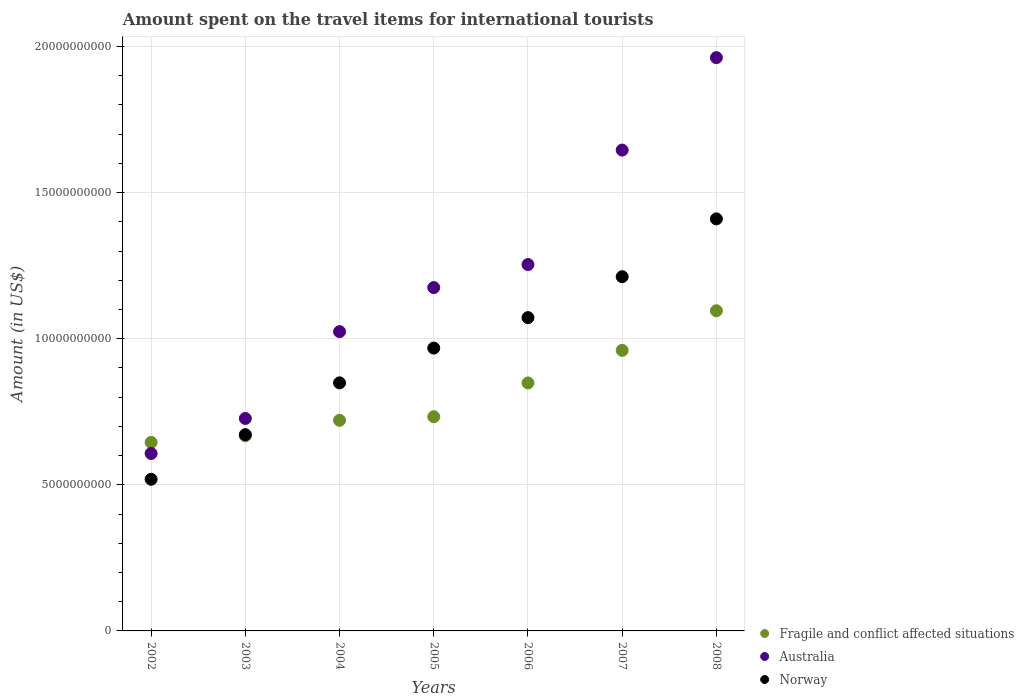Is the number of dotlines equal to the number of legend labels?
Keep it short and to the point. Yes. What is the amount spent on the travel items for international tourists in Australia in 2004?
Keep it short and to the point. 1.02e+1. Across all years, what is the maximum amount spent on the travel items for international tourists in Fragile and conflict affected situations?
Your answer should be compact. 1.10e+1. Across all years, what is the minimum amount spent on the travel items for international tourists in Fragile and conflict affected situations?
Offer a terse response. 6.45e+09. What is the total amount spent on the travel items for international tourists in Fragile and conflict affected situations in the graph?
Provide a succinct answer. 5.67e+1. What is the difference between the amount spent on the travel items for international tourists in Australia in 2003 and that in 2006?
Offer a very short reply. -5.27e+09. What is the difference between the amount spent on the travel items for international tourists in Australia in 2002 and the amount spent on the travel items for international tourists in Norway in 2008?
Make the answer very short. -8.03e+09. What is the average amount spent on the travel items for international tourists in Fragile and conflict affected situations per year?
Keep it short and to the point. 8.10e+09. In the year 2004, what is the difference between the amount spent on the travel items for international tourists in Norway and amount spent on the travel items for international tourists in Australia?
Provide a succinct answer. -1.75e+09. In how many years, is the amount spent on the travel items for international tourists in Norway greater than 17000000000 US$?
Offer a very short reply. 0. What is the ratio of the amount spent on the travel items for international tourists in Australia in 2006 to that in 2007?
Provide a succinct answer. 0.76. Is the amount spent on the travel items for international tourists in Fragile and conflict affected situations in 2002 less than that in 2006?
Your answer should be very brief. Yes. Is the difference between the amount spent on the travel items for international tourists in Norway in 2004 and 2006 greater than the difference between the amount spent on the travel items for international tourists in Australia in 2004 and 2006?
Your response must be concise. Yes. What is the difference between the highest and the second highest amount spent on the travel items for international tourists in Australia?
Offer a very short reply. 3.16e+09. What is the difference between the highest and the lowest amount spent on the travel items for international tourists in Australia?
Your answer should be compact. 1.35e+1. In how many years, is the amount spent on the travel items for international tourists in Fragile and conflict affected situations greater than the average amount spent on the travel items for international tourists in Fragile and conflict affected situations taken over all years?
Ensure brevity in your answer.  3. Is it the case that in every year, the sum of the amount spent on the travel items for international tourists in Fragile and conflict affected situations and amount spent on the travel items for international tourists in Norway  is greater than the amount spent on the travel items for international tourists in Australia?
Offer a terse response. Yes. Is the amount spent on the travel items for international tourists in Australia strictly less than the amount spent on the travel items for international tourists in Fragile and conflict affected situations over the years?
Your response must be concise. No. How many years are there in the graph?
Provide a succinct answer. 7. What is the difference between two consecutive major ticks on the Y-axis?
Keep it short and to the point. 5.00e+09. Does the graph contain any zero values?
Provide a succinct answer. No. Where does the legend appear in the graph?
Your response must be concise. Bottom right. What is the title of the graph?
Keep it short and to the point. Amount spent on the travel items for international tourists. Does "Kazakhstan" appear as one of the legend labels in the graph?
Your answer should be compact. No. What is the label or title of the Y-axis?
Your response must be concise. Amount (in US$). What is the Amount (in US$) in Fragile and conflict affected situations in 2002?
Your answer should be compact. 6.45e+09. What is the Amount (in US$) in Australia in 2002?
Offer a very short reply. 6.07e+09. What is the Amount (in US$) in Norway in 2002?
Give a very brief answer. 5.19e+09. What is the Amount (in US$) in Fragile and conflict affected situations in 2003?
Ensure brevity in your answer.  6.68e+09. What is the Amount (in US$) in Australia in 2003?
Offer a terse response. 7.27e+09. What is the Amount (in US$) of Norway in 2003?
Your answer should be very brief. 6.72e+09. What is the Amount (in US$) of Fragile and conflict affected situations in 2004?
Provide a short and direct response. 7.21e+09. What is the Amount (in US$) in Australia in 2004?
Keep it short and to the point. 1.02e+1. What is the Amount (in US$) of Norway in 2004?
Provide a succinct answer. 8.49e+09. What is the Amount (in US$) of Fragile and conflict affected situations in 2005?
Ensure brevity in your answer.  7.33e+09. What is the Amount (in US$) of Australia in 2005?
Provide a short and direct response. 1.17e+1. What is the Amount (in US$) of Norway in 2005?
Keep it short and to the point. 9.68e+09. What is the Amount (in US$) in Fragile and conflict affected situations in 2006?
Ensure brevity in your answer.  8.49e+09. What is the Amount (in US$) of Australia in 2006?
Provide a short and direct response. 1.25e+1. What is the Amount (in US$) of Norway in 2006?
Offer a terse response. 1.07e+1. What is the Amount (in US$) of Fragile and conflict affected situations in 2007?
Give a very brief answer. 9.60e+09. What is the Amount (in US$) of Australia in 2007?
Offer a very short reply. 1.65e+1. What is the Amount (in US$) of Norway in 2007?
Your response must be concise. 1.21e+1. What is the Amount (in US$) in Fragile and conflict affected situations in 2008?
Offer a very short reply. 1.10e+1. What is the Amount (in US$) of Australia in 2008?
Provide a succinct answer. 1.96e+1. What is the Amount (in US$) of Norway in 2008?
Your answer should be compact. 1.41e+1. Across all years, what is the maximum Amount (in US$) of Fragile and conflict affected situations?
Give a very brief answer. 1.10e+1. Across all years, what is the maximum Amount (in US$) in Australia?
Provide a short and direct response. 1.96e+1. Across all years, what is the maximum Amount (in US$) of Norway?
Ensure brevity in your answer.  1.41e+1. Across all years, what is the minimum Amount (in US$) in Fragile and conflict affected situations?
Your answer should be very brief. 6.45e+09. Across all years, what is the minimum Amount (in US$) in Australia?
Make the answer very short. 6.07e+09. Across all years, what is the minimum Amount (in US$) of Norway?
Your answer should be compact. 5.19e+09. What is the total Amount (in US$) in Fragile and conflict affected situations in the graph?
Offer a terse response. 5.67e+1. What is the total Amount (in US$) of Australia in the graph?
Provide a short and direct response. 8.39e+1. What is the total Amount (in US$) in Norway in the graph?
Make the answer very short. 6.70e+1. What is the difference between the Amount (in US$) in Fragile and conflict affected situations in 2002 and that in 2003?
Ensure brevity in your answer.  -2.28e+08. What is the difference between the Amount (in US$) in Australia in 2002 and that in 2003?
Make the answer very short. -1.20e+09. What is the difference between the Amount (in US$) in Norway in 2002 and that in 2003?
Keep it short and to the point. -1.53e+09. What is the difference between the Amount (in US$) of Fragile and conflict affected situations in 2002 and that in 2004?
Ensure brevity in your answer.  -7.56e+08. What is the difference between the Amount (in US$) of Australia in 2002 and that in 2004?
Your response must be concise. -4.17e+09. What is the difference between the Amount (in US$) in Norway in 2002 and that in 2004?
Provide a succinct answer. -3.30e+09. What is the difference between the Amount (in US$) of Fragile and conflict affected situations in 2002 and that in 2005?
Your answer should be compact. -8.79e+08. What is the difference between the Amount (in US$) in Australia in 2002 and that in 2005?
Provide a succinct answer. -5.68e+09. What is the difference between the Amount (in US$) in Norway in 2002 and that in 2005?
Offer a terse response. -4.49e+09. What is the difference between the Amount (in US$) of Fragile and conflict affected situations in 2002 and that in 2006?
Make the answer very short. -2.03e+09. What is the difference between the Amount (in US$) in Australia in 2002 and that in 2006?
Your answer should be compact. -6.46e+09. What is the difference between the Amount (in US$) in Norway in 2002 and that in 2006?
Offer a very short reply. -5.53e+09. What is the difference between the Amount (in US$) in Fragile and conflict affected situations in 2002 and that in 2007?
Your answer should be very brief. -3.15e+09. What is the difference between the Amount (in US$) of Australia in 2002 and that in 2007?
Your answer should be compact. -1.04e+1. What is the difference between the Amount (in US$) of Norway in 2002 and that in 2007?
Provide a short and direct response. -6.93e+09. What is the difference between the Amount (in US$) in Fragile and conflict affected situations in 2002 and that in 2008?
Give a very brief answer. -4.50e+09. What is the difference between the Amount (in US$) of Australia in 2002 and that in 2008?
Make the answer very short. -1.35e+1. What is the difference between the Amount (in US$) of Norway in 2002 and that in 2008?
Make the answer very short. -8.91e+09. What is the difference between the Amount (in US$) of Fragile and conflict affected situations in 2003 and that in 2004?
Offer a very short reply. -5.28e+08. What is the difference between the Amount (in US$) of Australia in 2003 and that in 2004?
Make the answer very short. -2.97e+09. What is the difference between the Amount (in US$) in Norway in 2003 and that in 2004?
Your answer should be compact. -1.77e+09. What is the difference between the Amount (in US$) in Fragile and conflict affected situations in 2003 and that in 2005?
Offer a terse response. -6.51e+08. What is the difference between the Amount (in US$) in Australia in 2003 and that in 2005?
Give a very brief answer. -4.48e+09. What is the difference between the Amount (in US$) of Norway in 2003 and that in 2005?
Your answer should be compact. -2.96e+09. What is the difference between the Amount (in US$) of Fragile and conflict affected situations in 2003 and that in 2006?
Give a very brief answer. -1.81e+09. What is the difference between the Amount (in US$) of Australia in 2003 and that in 2006?
Offer a very short reply. -5.27e+09. What is the difference between the Amount (in US$) in Norway in 2003 and that in 2006?
Your answer should be very brief. -4.00e+09. What is the difference between the Amount (in US$) of Fragile and conflict affected situations in 2003 and that in 2007?
Ensure brevity in your answer.  -2.92e+09. What is the difference between the Amount (in US$) in Australia in 2003 and that in 2007?
Your answer should be very brief. -9.18e+09. What is the difference between the Amount (in US$) of Norway in 2003 and that in 2007?
Keep it short and to the point. -5.40e+09. What is the difference between the Amount (in US$) in Fragile and conflict affected situations in 2003 and that in 2008?
Your answer should be very brief. -4.28e+09. What is the difference between the Amount (in US$) in Australia in 2003 and that in 2008?
Keep it short and to the point. -1.23e+1. What is the difference between the Amount (in US$) in Norway in 2003 and that in 2008?
Keep it short and to the point. -7.38e+09. What is the difference between the Amount (in US$) of Fragile and conflict affected situations in 2004 and that in 2005?
Provide a succinct answer. -1.23e+08. What is the difference between the Amount (in US$) of Australia in 2004 and that in 2005?
Give a very brief answer. -1.51e+09. What is the difference between the Amount (in US$) of Norway in 2004 and that in 2005?
Offer a terse response. -1.19e+09. What is the difference between the Amount (in US$) of Fragile and conflict affected situations in 2004 and that in 2006?
Your answer should be compact. -1.28e+09. What is the difference between the Amount (in US$) in Australia in 2004 and that in 2006?
Provide a short and direct response. -2.30e+09. What is the difference between the Amount (in US$) of Norway in 2004 and that in 2006?
Ensure brevity in your answer.  -2.23e+09. What is the difference between the Amount (in US$) of Fragile and conflict affected situations in 2004 and that in 2007?
Your answer should be compact. -2.39e+09. What is the difference between the Amount (in US$) of Australia in 2004 and that in 2007?
Provide a succinct answer. -6.21e+09. What is the difference between the Amount (in US$) of Norway in 2004 and that in 2007?
Your response must be concise. -3.63e+09. What is the difference between the Amount (in US$) in Fragile and conflict affected situations in 2004 and that in 2008?
Your answer should be compact. -3.75e+09. What is the difference between the Amount (in US$) of Australia in 2004 and that in 2008?
Offer a very short reply. -9.38e+09. What is the difference between the Amount (in US$) in Norway in 2004 and that in 2008?
Your response must be concise. -5.61e+09. What is the difference between the Amount (in US$) in Fragile and conflict affected situations in 2005 and that in 2006?
Offer a terse response. -1.16e+09. What is the difference between the Amount (in US$) of Australia in 2005 and that in 2006?
Provide a succinct answer. -7.88e+08. What is the difference between the Amount (in US$) in Norway in 2005 and that in 2006?
Keep it short and to the point. -1.04e+09. What is the difference between the Amount (in US$) in Fragile and conflict affected situations in 2005 and that in 2007?
Your answer should be compact. -2.27e+09. What is the difference between the Amount (in US$) in Australia in 2005 and that in 2007?
Provide a short and direct response. -4.70e+09. What is the difference between the Amount (in US$) in Norway in 2005 and that in 2007?
Ensure brevity in your answer.  -2.44e+09. What is the difference between the Amount (in US$) of Fragile and conflict affected situations in 2005 and that in 2008?
Your answer should be very brief. -3.63e+09. What is the difference between the Amount (in US$) in Australia in 2005 and that in 2008?
Provide a short and direct response. -7.87e+09. What is the difference between the Amount (in US$) in Norway in 2005 and that in 2008?
Ensure brevity in your answer.  -4.42e+09. What is the difference between the Amount (in US$) of Fragile and conflict affected situations in 2006 and that in 2007?
Give a very brief answer. -1.11e+09. What is the difference between the Amount (in US$) of Australia in 2006 and that in 2007?
Keep it short and to the point. -3.92e+09. What is the difference between the Amount (in US$) of Norway in 2006 and that in 2007?
Provide a short and direct response. -1.40e+09. What is the difference between the Amount (in US$) in Fragile and conflict affected situations in 2006 and that in 2008?
Your answer should be compact. -2.47e+09. What is the difference between the Amount (in US$) in Australia in 2006 and that in 2008?
Keep it short and to the point. -7.08e+09. What is the difference between the Amount (in US$) of Norway in 2006 and that in 2008?
Offer a terse response. -3.38e+09. What is the difference between the Amount (in US$) in Fragile and conflict affected situations in 2007 and that in 2008?
Provide a succinct answer. -1.35e+09. What is the difference between the Amount (in US$) in Australia in 2007 and that in 2008?
Keep it short and to the point. -3.16e+09. What is the difference between the Amount (in US$) in Norway in 2007 and that in 2008?
Provide a succinct answer. -1.98e+09. What is the difference between the Amount (in US$) in Fragile and conflict affected situations in 2002 and the Amount (in US$) in Australia in 2003?
Your answer should be compact. -8.19e+08. What is the difference between the Amount (in US$) in Fragile and conflict affected situations in 2002 and the Amount (in US$) in Norway in 2003?
Give a very brief answer. -2.65e+08. What is the difference between the Amount (in US$) of Australia in 2002 and the Amount (in US$) of Norway in 2003?
Offer a very short reply. -6.44e+08. What is the difference between the Amount (in US$) in Fragile and conflict affected situations in 2002 and the Amount (in US$) in Australia in 2004?
Keep it short and to the point. -3.79e+09. What is the difference between the Amount (in US$) in Fragile and conflict affected situations in 2002 and the Amount (in US$) in Norway in 2004?
Offer a terse response. -2.04e+09. What is the difference between the Amount (in US$) of Australia in 2002 and the Amount (in US$) of Norway in 2004?
Provide a succinct answer. -2.42e+09. What is the difference between the Amount (in US$) in Fragile and conflict affected situations in 2002 and the Amount (in US$) in Australia in 2005?
Make the answer very short. -5.30e+09. What is the difference between the Amount (in US$) of Fragile and conflict affected situations in 2002 and the Amount (in US$) of Norway in 2005?
Your answer should be compact. -3.23e+09. What is the difference between the Amount (in US$) of Australia in 2002 and the Amount (in US$) of Norway in 2005?
Offer a very short reply. -3.61e+09. What is the difference between the Amount (in US$) in Fragile and conflict affected situations in 2002 and the Amount (in US$) in Australia in 2006?
Make the answer very short. -6.09e+09. What is the difference between the Amount (in US$) in Fragile and conflict affected situations in 2002 and the Amount (in US$) in Norway in 2006?
Your answer should be very brief. -4.27e+09. What is the difference between the Amount (in US$) of Australia in 2002 and the Amount (in US$) of Norway in 2006?
Your response must be concise. -4.65e+09. What is the difference between the Amount (in US$) of Fragile and conflict affected situations in 2002 and the Amount (in US$) of Australia in 2007?
Provide a short and direct response. -1.00e+1. What is the difference between the Amount (in US$) in Fragile and conflict affected situations in 2002 and the Amount (in US$) in Norway in 2007?
Provide a short and direct response. -5.67e+09. What is the difference between the Amount (in US$) in Australia in 2002 and the Amount (in US$) in Norway in 2007?
Keep it short and to the point. -6.05e+09. What is the difference between the Amount (in US$) in Fragile and conflict affected situations in 2002 and the Amount (in US$) in Australia in 2008?
Provide a succinct answer. -1.32e+1. What is the difference between the Amount (in US$) of Fragile and conflict affected situations in 2002 and the Amount (in US$) of Norway in 2008?
Your answer should be very brief. -7.65e+09. What is the difference between the Amount (in US$) of Australia in 2002 and the Amount (in US$) of Norway in 2008?
Your answer should be very brief. -8.03e+09. What is the difference between the Amount (in US$) of Fragile and conflict affected situations in 2003 and the Amount (in US$) of Australia in 2004?
Your response must be concise. -3.56e+09. What is the difference between the Amount (in US$) of Fragile and conflict affected situations in 2003 and the Amount (in US$) of Norway in 2004?
Your answer should be compact. -1.81e+09. What is the difference between the Amount (in US$) of Australia in 2003 and the Amount (in US$) of Norway in 2004?
Your answer should be compact. -1.22e+09. What is the difference between the Amount (in US$) in Fragile and conflict affected situations in 2003 and the Amount (in US$) in Australia in 2005?
Ensure brevity in your answer.  -5.07e+09. What is the difference between the Amount (in US$) in Fragile and conflict affected situations in 2003 and the Amount (in US$) in Norway in 2005?
Provide a short and direct response. -3.00e+09. What is the difference between the Amount (in US$) in Australia in 2003 and the Amount (in US$) in Norway in 2005?
Offer a terse response. -2.41e+09. What is the difference between the Amount (in US$) of Fragile and conflict affected situations in 2003 and the Amount (in US$) of Australia in 2006?
Make the answer very short. -5.86e+09. What is the difference between the Amount (in US$) in Fragile and conflict affected situations in 2003 and the Amount (in US$) in Norway in 2006?
Ensure brevity in your answer.  -4.04e+09. What is the difference between the Amount (in US$) of Australia in 2003 and the Amount (in US$) of Norway in 2006?
Offer a very short reply. -3.45e+09. What is the difference between the Amount (in US$) in Fragile and conflict affected situations in 2003 and the Amount (in US$) in Australia in 2007?
Your answer should be very brief. -9.77e+09. What is the difference between the Amount (in US$) in Fragile and conflict affected situations in 2003 and the Amount (in US$) in Norway in 2007?
Keep it short and to the point. -5.44e+09. What is the difference between the Amount (in US$) in Australia in 2003 and the Amount (in US$) in Norway in 2007?
Provide a short and direct response. -4.85e+09. What is the difference between the Amount (in US$) in Fragile and conflict affected situations in 2003 and the Amount (in US$) in Australia in 2008?
Make the answer very short. -1.29e+1. What is the difference between the Amount (in US$) of Fragile and conflict affected situations in 2003 and the Amount (in US$) of Norway in 2008?
Your response must be concise. -7.42e+09. What is the difference between the Amount (in US$) in Australia in 2003 and the Amount (in US$) in Norway in 2008?
Make the answer very short. -6.83e+09. What is the difference between the Amount (in US$) in Fragile and conflict affected situations in 2004 and the Amount (in US$) in Australia in 2005?
Offer a terse response. -4.54e+09. What is the difference between the Amount (in US$) in Fragile and conflict affected situations in 2004 and the Amount (in US$) in Norway in 2005?
Your answer should be very brief. -2.47e+09. What is the difference between the Amount (in US$) in Australia in 2004 and the Amount (in US$) in Norway in 2005?
Give a very brief answer. 5.64e+08. What is the difference between the Amount (in US$) of Fragile and conflict affected situations in 2004 and the Amount (in US$) of Australia in 2006?
Make the answer very short. -5.33e+09. What is the difference between the Amount (in US$) in Fragile and conflict affected situations in 2004 and the Amount (in US$) in Norway in 2006?
Your answer should be very brief. -3.51e+09. What is the difference between the Amount (in US$) in Australia in 2004 and the Amount (in US$) in Norway in 2006?
Ensure brevity in your answer.  -4.79e+08. What is the difference between the Amount (in US$) in Fragile and conflict affected situations in 2004 and the Amount (in US$) in Australia in 2007?
Give a very brief answer. -9.25e+09. What is the difference between the Amount (in US$) in Fragile and conflict affected situations in 2004 and the Amount (in US$) in Norway in 2007?
Offer a terse response. -4.91e+09. What is the difference between the Amount (in US$) of Australia in 2004 and the Amount (in US$) of Norway in 2007?
Make the answer very short. -1.88e+09. What is the difference between the Amount (in US$) in Fragile and conflict affected situations in 2004 and the Amount (in US$) in Australia in 2008?
Keep it short and to the point. -1.24e+1. What is the difference between the Amount (in US$) of Fragile and conflict affected situations in 2004 and the Amount (in US$) of Norway in 2008?
Offer a terse response. -6.89e+09. What is the difference between the Amount (in US$) of Australia in 2004 and the Amount (in US$) of Norway in 2008?
Your response must be concise. -3.86e+09. What is the difference between the Amount (in US$) of Fragile and conflict affected situations in 2005 and the Amount (in US$) of Australia in 2006?
Offer a very short reply. -5.21e+09. What is the difference between the Amount (in US$) of Fragile and conflict affected situations in 2005 and the Amount (in US$) of Norway in 2006?
Your response must be concise. -3.39e+09. What is the difference between the Amount (in US$) in Australia in 2005 and the Amount (in US$) in Norway in 2006?
Make the answer very short. 1.03e+09. What is the difference between the Amount (in US$) in Fragile and conflict affected situations in 2005 and the Amount (in US$) in Australia in 2007?
Ensure brevity in your answer.  -9.12e+09. What is the difference between the Amount (in US$) of Fragile and conflict affected situations in 2005 and the Amount (in US$) of Norway in 2007?
Provide a succinct answer. -4.79e+09. What is the difference between the Amount (in US$) in Australia in 2005 and the Amount (in US$) in Norway in 2007?
Your answer should be compact. -3.72e+08. What is the difference between the Amount (in US$) of Fragile and conflict affected situations in 2005 and the Amount (in US$) of Australia in 2008?
Offer a very short reply. -1.23e+1. What is the difference between the Amount (in US$) in Fragile and conflict affected situations in 2005 and the Amount (in US$) in Norway in 2008?
Offer a terse response. -6.77e+09. What is the difference between the Amount (in US$) of Australia in 2005 and the Amount (in US$) of Norway in 2008?
Ensure brevity in your answer.  -2.35e+09. What is the difference between the Amount (in US$) of Fragile and conflict affected situations in 2006 and the Amount (in US$) of Australia in 2007?
Make the answer very short. -7.97e+09. What is the difference between the Amount (in US$) in Fragile and conflict affected situations in 2006 and the Amount (in US$) in Norway in 2007?
Ensure brevity in your answer.  -3.63e+09. What is the difference between the Amount (in US$) in Australia in 2006 and the Amount (in US$) in Norway in 2007?
Keep it short and to the point. 4.16e+08. What is the difference between the Amount (in US$) in Fragile and conflict affected situations in 2006 and the Amount (in US$) in Australia in 2008?
Provide a short and direct response. -1.11e+1. What is the difference between the Amount (in US$) of Fragile and conflict affected situations in 2006 and the Amount (in US$) of Norway in 2008?
Ensure brevity in your answer.  -5.61e+09. What is the difference between the Amount (in US$) in Australia in 2006 and the Amount (in US$) in Norway in 2008?
Your response must be concise. -1.56e+09. What is the difference between the Amount (in US$) of Fragile and conflict affected situations in 2007 and the Amount (in US$) of Australia in 2008?
Offer a terse response. -1.00e+1. What is the difference between the Amount (in US$) in Fragile and conflict affected situations in 2007 and the Amount (in US$) in Norway in 2008?
Make the answer very short. -4.50e+09. What is the difference between the Amount (in US$) of Australia in 2007 and the Amount (in US$) of Norway in 2008?
Keep it short and to the point. 2.35e+09. What is the average Amount (in US$) of Fragile and conflict affected situations per year?
Offer a very short reply. 8.10e+09. What is the average Amount (in US$) in Australia per year?
Provide a short and direct response. 1.20e+1. What is the average Amount (in US$) in Norway per year?
Your answer should be very brief. 9.57e+09. In the year 2002, what is the difference between the Amount (in US$) of Fragile and conflict affected situations and Amount (in US$) of Australia?
Give a very brief answer. 3.79e+08. In the year 2002, what is the difference between the Amount (in US$) in Fragile and conflict affected situations and Amount (in US$) in Norway?
Make the answer very short. 1.26e+09. In the year 2002, what is the difference between the Amount (in US$) in Australia and Amount (in US$) in Norway?
Provide a short and direct response. 8.83e+08. In the year 2003, what is the difference between the Amount (in US$) in Fragile and conflict affected situations and Amount (in US$) in Australia?
Give a very brief answer. -5.91e+08. In the year 2003, what is the difference between the Amount (in US$) of Fragile and conflict affected situations and Amount (in US$) of Norway?
Provide a succinct answer. -3.69e+07. In the year 2003, what is the difference between the Amount (in US$) in Australia and Amount (in US$) in Norway?
Offer a very short reply. 5.54e+08. In the year 2004, what is the difference between the Amount (in US$) in Fragile and conflict affected situations and Amount (in US$) in Australia?
Provide a short and direct response. -3.03e+09. In the year 2004, what is the difference between the Amount (in US$) in Fragile and conflict affected situations and Amount (in US$) in Norway?
Provide a short and direct response. -1.28e+09. In the year 2004, what is the difference between the Amount (in US$) in Australia and Amount (in US$) in Norway?
Your answer should be compact. 1.75e+09. In the year 2005, what is the difference between the Amount (in US$) of Fragile and conflict affected situations and Amount (in US$) of Australia?
Make the answer very short. -4.42e+09. In the year 2005, what is the difference between the Amount (in US$) of Fragile and conflict affected situations and Amount (in US$) of Norway?
Ensure brevity in your answer.  -2.35e+09. In the year 2005, what is the difference between the Amount (in US$) of Australia and Amount (in US$) of Norway?
Your response must be concise. 2.07e+09. In the year 2006, what is the difference between the Amount (in US$) of Fragile and conflict affected situations and Amount (in US$) of Australia?
Keep it short and to the point. -4.05e+09. In the year 2006, what is the difference between the Amount (in US$) in Fragile and conflict affected situations and Amount (in US$) in Norway?
Provide a succinct answer. -2.23e+09. In the year 2006, what is the difference between the Amount (in US$) of Australia and Amount (in US$) of Norway?
Provide a succinct answer. 1.82e+09. In the year 2007, what is the difference between the Amount (in US$) of Fragile and conflict affected situations and Amount (in US$) of Australia?
Make the answer very short. -6.85e+09. In the year 2007, what is the difference between the Amount (in US$) of Fragile and conflict affected situations and Amount (in US$) of Norway?
Provide a succinct answer. -2.52e+09. In the year 2007, what is the difference between the Amount (in US$) in Australia and Amount (in US$) in Norway?
Your answer should be very brief. 4.33e+09. In the year 2008, what is the difference between the Amount (in US$) of Fragile and conflict affected situations and Amount (in US$) of Australia?
Your response must be concise. -8.66e+09. In the year 2008, what is the difference between the Amount (in US$) of Fragile and conflict affected situations and Amount (in US$) of Norway?
Your answer should be compact. -3.14e+09. In the year 2008, what is the difference between the Amount (in US$) of Australia and Amount (in US$) of Norway?
Provide a succinct answer. 5.52e+09. What is the ratio of the Amount (in US$) in Fragile and conflict affected situations in 2002 to that in 2003?
Keep it short and to the point. 0.97. What is the ratio of the Amount (in US$) in Australia in 2002 to that in 2003?
Offer a very short reply. 0.84. What is the ratio of the Amount (in US$) of Norway in 2002 to that in 2003?
Ensure brevity in your answer.  0.77. What is the ratio of the Amount (in US$) in Fragile and conflict affected situations in 2002 to that in 2004?
Ensure brevity in your answer.  0.9. What is the ratio of the Amount (in US$) in Australia in 2002 to that in 2004?
Offer a terse response. 0.59. What is the ratio of the Amount (in US$) in Norway in 2002 to that in 2004?
Provide a short and direct response. 0.61. What is the ratio of the Amount (in US$) of Fragile and conflict affected situations in 2002 to that in 2005?
Your answer should be very brief. 0.88. What is the ratio of the Amount (in US$) in Australia in 2002 to that in 2005?
Make the answer very short. 0.52. What is the ratio of the Amount (in US$) in Norway in 2002 to that in 2005?
Offer a terse response. 0.54. What is the ratio of the Amount (in US$) in Fragile and conflict affected situations in 2002 to that in 2006?
Your answer should be compact. 0.76. What is the ratio of the Amount (in US$) of Australia in 2002 to that in 2006?
Your response must be concise. 0.48. What is the ratio of the Amount (in US$) of Norway in 2002 to that in 2006?
Your response must be concise. 0.48. What is the ratio of the Amount (in US$) in Fragile and conflict affected situations in 2002 to that in 2007?
Offer a very short reply. 0.67. What is the ratio of the Amount (in US$) of Australia in 2002 to that in 2007?
Offer a terse response. 0.37. What is the ratio of the Amount (in US$) in Norway in 2002 to that in 2007?
Keep it short and to the point. 0.43. What is the ratio of the Amount (in US$) in Fragile and conflict affected situations in 2002 to that in 2008?
Your answer should be compact. 0.59. What is the ratio of the Amount (in US$) of Australia in 2002 to that in 2008?
Your answer should be very brief. 0.31. What is the ratio of the Amount (in US$) of Norway in 2002 to that in 2008?
Keep it short and to the point. 0.37. What is the ratio of the Amount (in US$) in Fragile and conflict affected situations in 2003 to that in 2004?
Your answer should be very brief. 0.93. What is the ratio of the Amount (in US$) of Australia in 2003 to that in 2004?
Your answer should be compact. 0.71. What is the ratio of the Amount (in US$) in Norway in 2003 to that in 2004?
Your response must be concise. 0.79. What is the ratio of the Amount (in US$) in Fragile and conflict affected situations in 2003 to that in 2005?
Your response must be concise. 0.91. What is the ratio of the Amount (in US$) of Australia in 2003 to that in 2005?
Offer a very short reply. 0.62. What is the ratio of the Amount (in US$) in Norway in 2003 to that in 2005?
Ensure brevity in your answer.  0.69. What is the ratio of the Amount (in US$) of Fragile and conflict affected situations in 2003 to that in 2006?
Your answer should be compact. 0.79. What is the ratio of the Amount (in US$) in Australia in 2003 to that in 2006?
Your answer should be very brief. 0.58. What is the ratio of the Amount (in US$) of Norway in 2003 to that in 2006?
Provide a succinct answer. 0.63. What is the ratio of the Amount (in US$) of Fragile and conflict affected situations in 2003 to that in 2007?
Your answer should be compact. 0.7. What is the ratio of the Amount (in US$) in Australia in 2003 to that in 2007?
Your response must be concise. 0.44. What is the ratio of the Amount (in US$) of Norway in 2003 to that in 2007?
Your response must be concise. 0.55. What is the ratio of the Amount (in US$) of Fragile and conflict affected situations in 2003 to that in 2008?
Give a very brief answer. 0.61. What is the ratio of the Amount (in US$) of Australia in 2003 to that in 2008?
Ensure brevity in your answer.  0.37. What is the ratio of the Amount (in US$) in Norway in 2003 to that in 2008?
Ensure brevity in your answer.  0.48. What is the ratio of the Amount (in US$) of Fragile and conflict affected situations in 2004 to that in 2005?
Your answer should be very brief. 0.98. What is the ratio of the Amount (in US$) of Australia in 2004 to that in 2005?
Keep it short and to the point. 0.87. What is the ratio of the Amount (in US$) of Norway in 2004 to that in 2005?
Offer a terse response. 0.88. What is the ratio of the Amount (in US$) in Fragile and conflict affected situations in 2004 to that in 2006?
Provide a succinct answer. 0.85. What is the ratio of the Amount (in US$) of Australia in 2004 to that in 2006?
Provide a succinct answer. 0.82. What is the ratio of the Amount (in US$) in Norway in 2004 to that in 2006?
Provide a short and direct response. 0.79. What is the ratio of the Amount (in US$) of Fragile and conflict affected situations in 2004 to that in 2007?
Keep it short and to the point. 0.75. What is the ratio of the Amount (in US$) of Australia in 2004 to that in 2007?
Offer a terse response. 0.62. What is the ratio of the Amount (in US$) of Norway in 2004 to that in 2007?
Your answer should be compact. 0.7. What is the ratio of the Amount (in US$) in Fragile and conflict affected situations in 2004 to that in 2008?
Ensure brevity in your answer.  0.66. What is the ratio of the Amount (in US$) of Australia in 2004 to that in 2008?
Your response must be concise. 0.52. What is the ratio of the Amount (in US$) in Norway in 2004 to that in 2008?
Ensure brevity in your answer.  0.6. What is the ratio of the Amount (in US$) of Fragile and conflict affected situations in 2005 to that in 2006?
Provide a short and direct response. 0.86. What is the ratio of the Amount (in US$) of Australia in 2005 to that in 2006?
Offer a terse response. 0.94. What is the ratio of the Amount (in US$) in Norway in 2005 to that in 2006?
Provide a short and direct response. 0.9. What is the ratio of the Amount (in US$) in Fragile and conflict affected situations in 2005 to that in 2007?
Keep it short and to the point. 0.76. What is the ratio of the Amount (in US$) of Australia in 2005 to that in 2007?
Offer a terse response. 0.71. What is the ratio of the Amount (in US$) in Norway in 2005 to that in 2007?
Keep it short and to the point. 0.8. What is the ratio of the Amount (in US$) of Fragile and conflict affected situations in 2005 to that in 2008?
Ensure brevity in your answer.  0.67. What is the ratio of the Amount (in US$) in Australia in 2005 to that in 2008?
Provide a short and direct response. 0.6. What is the ratio of the Amount (in US$) in Norway in 2005 to that in 2008?
Ensure brevity in your answer.  0.69. What is the ratio of the Amount (in US$) in Fragile and conflict affected situations in 2006 to that in 2007?
Ensure brevity in your answer.  0.88. What is the ratio of the Amount (in US$) in Australia in 2006 to that in 2007?
Your answer should be compact. 0.76. What is the ratio of the Amount (in US$) of Norway in 2006 to that in 2007?
Offer a very short reply. 0.88. What is the ratio of the Amount (in US$) of Fragile and conflict affected situations in 2006 to that in 2008?
Ensure brevity in your answer.  0.77. What is the ratio of the Amount (in US$) in Australia in 2006 to that in 2008?
Offer a very short reply. 0.64. What is the ratio of the Amount (in US$) of Norway in 2006 to that in 2008?
Your answer should be very brief. 0.76. What is the ratio of the Amount (in US$) in Fragile and conflict affected situations in 2007 to that in 2008?
Ensure brevity in your answer.  0.88. What is the ratio of the Amount (in US$) of Australia in 2007 to that in 2008?
Your answer should be very brief. 0.84. What is the ratio of the Amount (in US$) in Norway in 2007 to that in 2008?
Your answer should be very brief. 0.86. What is the difference between the highest and the second highest Amount (in US$) in Fragile and conflict affected situations?
Offer a very short reply. 1.35e+09. What is the difference between the highest and the second highest Amount (in US$) in Australia?
Make the answer very short. 3.16e+09. What is the difference between the highest and the second highest Amount (in US$) of Norway?
Your response must be concise. 1.98e+09. What is the difference between the highest and the lowest Amount (in US$) in Fragile and conflict affected situations?
Ensure brevity in your answer.  4.50e+09. What is the difference between the highest and the lowest Amount (in US$) in Australia?
Your answer should be compact. 1.35e+1. What is the difference between the highest and the lowest Amount (in US$) in Norway?
Provide a short and direct response. 8.91e+09. 